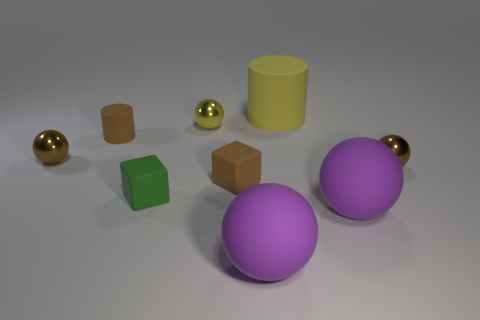There is a tiny ball that is to the right of the green matte object and in front of the tiny yellow metal object; what color is it?
Provide a succinct answer. Brown. Is the number of balls that are left of the yellow rubber cylinder greater than the number of purple balls behind the brown matte cube?
Give a very brief answer. Yes. The green thing that is the same material as the yellow cylinder is what size?
Provide a succinct answer. Small. There is a small brown rubber object to the left of the tiny green rubber thing; how many small yellow objects are behind it?
Keep it short and to the point. 1. Are there any other small rubber objects of the same shape as the tiny green thing?
Ensure brevity in your answer.  Yes. There is a small rubber thing that is behind the brown thing right of the large yellow rubber cylinder; what is its color?
Keep it short and to the point. Brown. Are there more purple matte spheres than small things?
Ensure brevity in your answer.  No. What number of yellow things have the same size as the brown matte cube?
Provide a succinct answer. 1. Are the small yellow ball and the tiny cube that is in front of the small brown block made of the same material?
Keep it short and to the point. No. Are there fewer metal things than small cyan matte cylinders?
Ensure brevity in your answer.  No. 